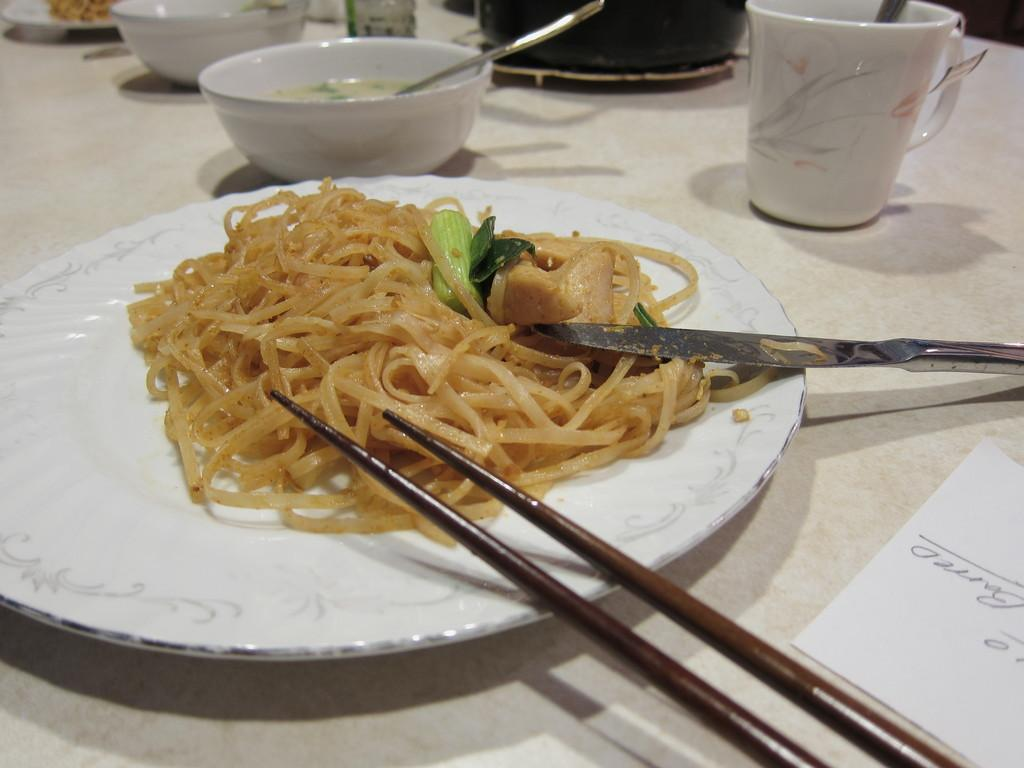What type of dish is on the white plate in the image? The plate contains spaghetti food. What utensils are present in the image? There are chopsticks and a knife in the image. Where are the objects placed in the image? The objects are placed on a table. What other items can be seen on the table? There is a cup, bowls, and a piece of paper on the table. What type of polish is being applied to the table in the image? There is no polish or any indication of polishing activity in the image. 